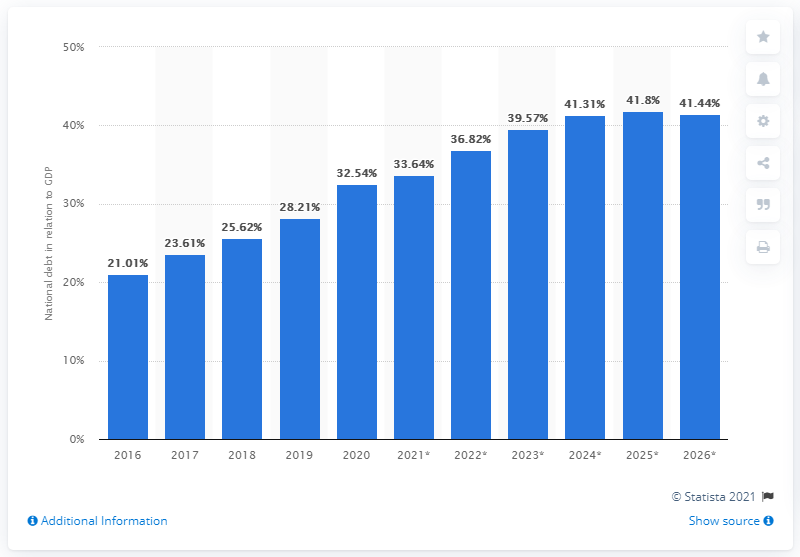List a handful of essential elements in this visual. In 2020, the national debt of Chile was equivalent to approximately 17.7% of the country's Gross Domestic Product (GDP). 